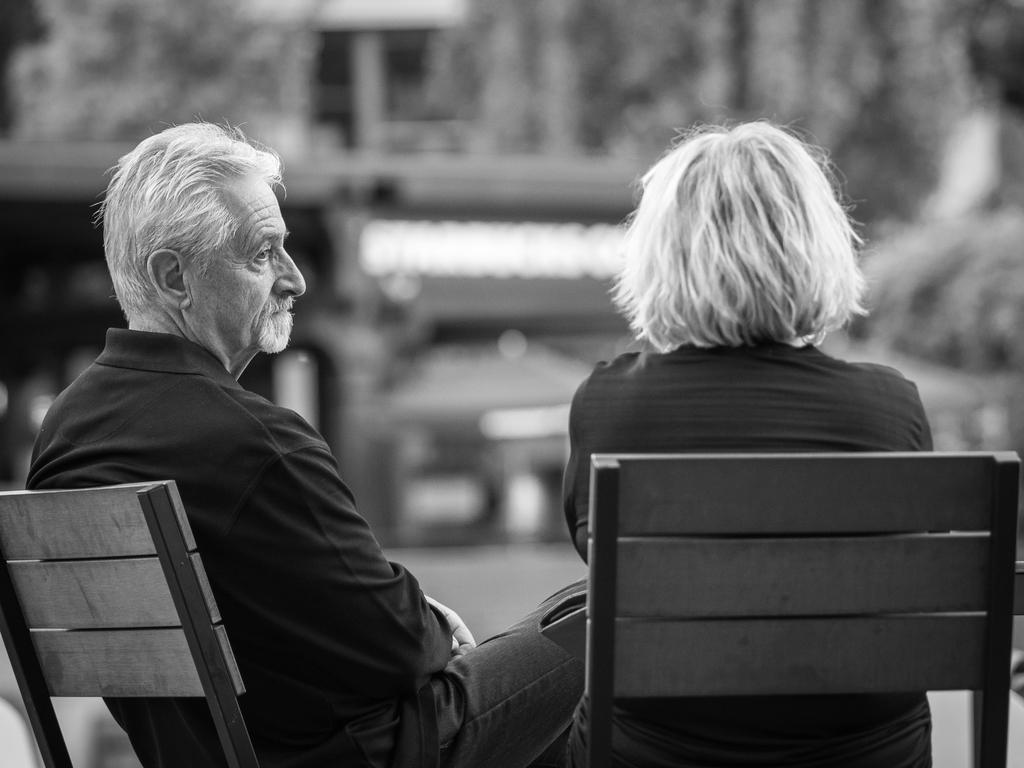Could you give a brief overview of what you see in this image? In this image, in the foreground I can see, there are two people sitting on the chair, and the background is blurry. 